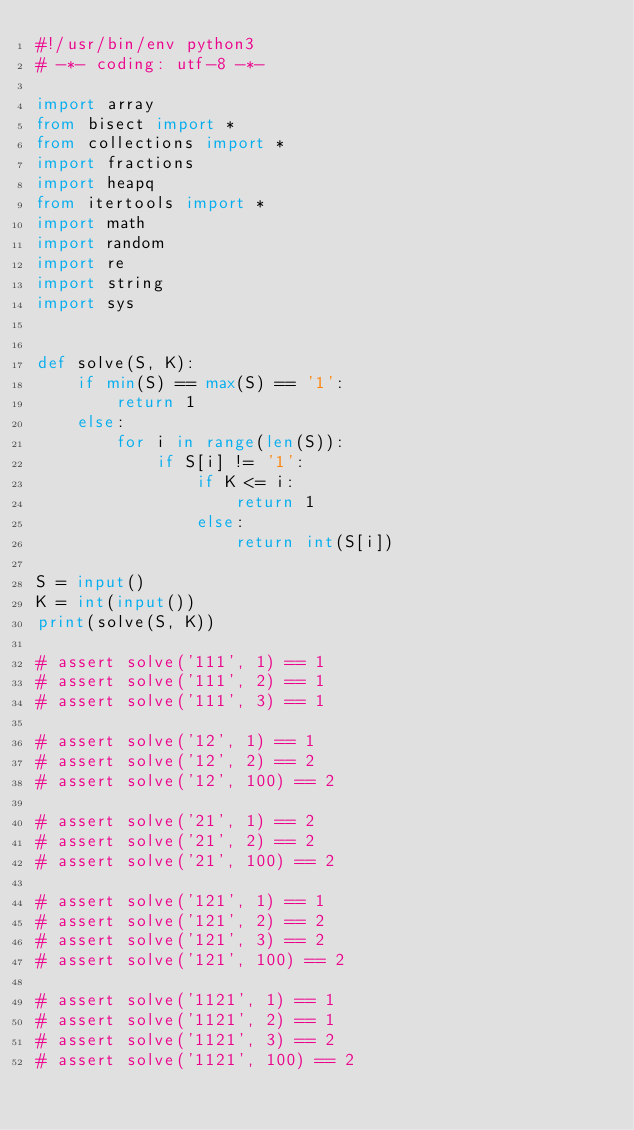Convert code to text. <code><loc_0><loc_0><loc_500><loc_500><_Python_>#!/usr/bin/env python3
# -*- coding: utf-8 -*-

import array
from bisect import *
from collections import *
import fractions
import heapq
from itertools import *
import math
import random
import re
import string
import sys


def solve(S, K):
    if min(S) == max(S) == '1':
        return 1
    else:
        for i in range(len(S)):
            if S[i] != '1':
                if K <= i:
                    return 1
                else:
                    return int(S[i])

S = input()
K = int(input())
print(solve(S, K))                

# assert solve('111', 1) == 1
# assert solve('111', 2) == 1
# assert solve('111', 3) == 1

# assert solve('12', 1) == 1
# assert solve('12', 2) == 2
# assert solve('12', 100) == 2

# assert solve('21', 1) == 2
# assert solve('21', 2) == 2
# assert solve('21', 100) == 2

# assert solve('121', 1) == 1
# assert solve('121', 2) == 2
# assert solve('121', 3) == 2
# assert solve('121', 100) == 2

# assert solve('1121', 1) == 1
# assert solve('1121', 2) == 1
# assert solve('1121', 3) == 2
# assert solve('1121', 100) == 2
</code> 